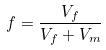<formula> <loc_0><loc_0><loc_500><loc_500>f = \frac { V _ { f } } { V _ { f } + V _ { m } }</formula> 